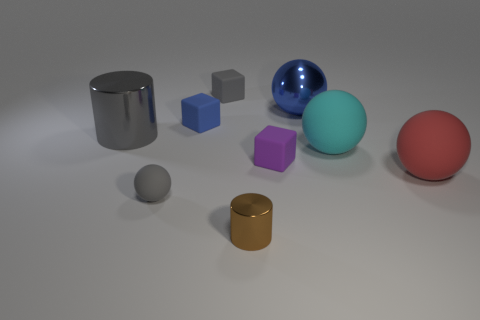Subtract all tiny blue matte cubes. How many cubes are left? 2 Subtract all brown cylinders. How many cylinders are left? 1 Subtract 2 balls. How many balls are left? 2 Add 1 small blue matte blocks. How many objects exist? 10 Subtract all blocks. How many objects are left? 6 Subtract all cyan balls. Subtract all yellow cylinders. How many balls are left? 3 Add 9 small purple things. How many small purple things are left? 10 Add 2 red rubber balls. How many red rubber balls exist? 3 Subtract 0 green spheres. How many objects are left? 9 Subtract all brown metallic cylinders. Subtract all big cyan rubber objects. How many objects are left? 7 